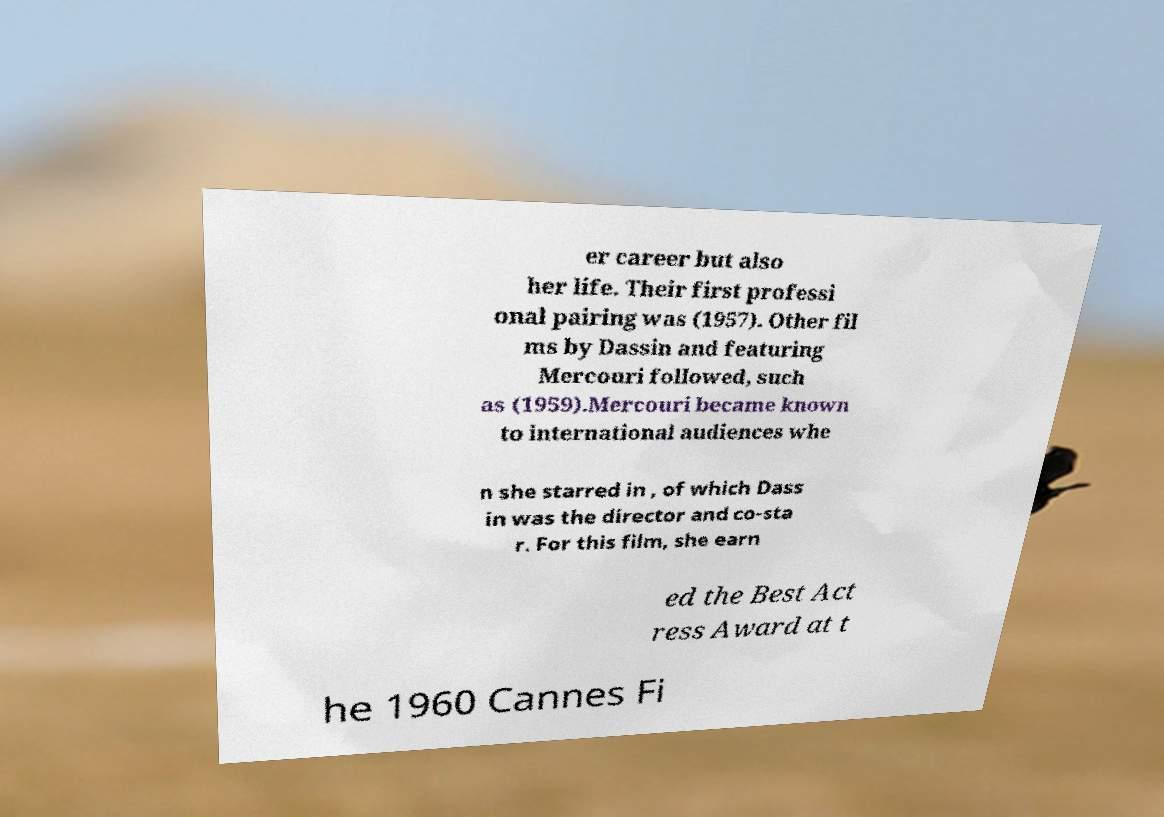Could you extract and type out the text from this image? er career but also her life. Their first professi onal pairing was (1957). Other fil ms by Dassin and featuring Mercouri followed, such as (1959).Mercouri became known to international audiences whe n she starred in , of which Dass in was the director and co-sta r. For this film, she earn ed the Best Act ress Award at t he 1960 Cannes Fi 